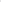<chart> <loc_0><loc_0><loc_500><loc_500><pie_chart><fcel>Total debt<fcel>Total equity<fcel>Total capitalization<nl><fcel>13.74%<fcel>36.26%<fcel>50.0%<nl></chart> 